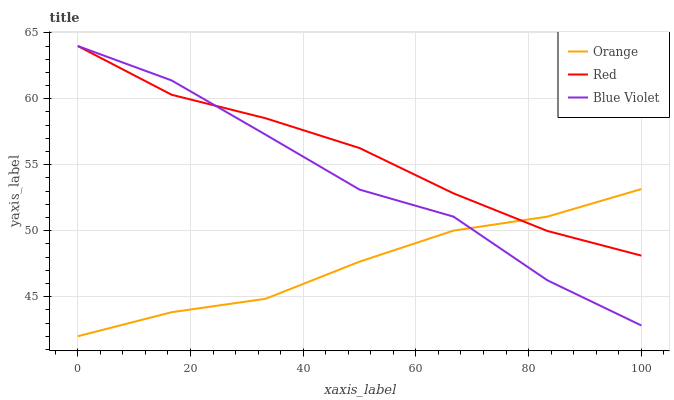Does Orange have the minimum area under the curve?
Answer yes or no. Yes. Does Red have the maximum area under the curve?
Answer yes or no. Yes. Does Blue Violet have the minimum area under the curve?
Answer yes or no. No. Does Blue Violet have the maximum area under the curve?
Answer yes or no. No. Is Red the smoothest?
Answer yes or no. Yes. Is Blue Violet the roughest?
Answer yes or no. Yes. Is Blue Violet the smoothest?
Answer yes or no. No. Is Red the roughest?
Answer yes or no. No. Does Orange have the lowest value?
Answer yes or no. Yes. Does Blue Violet have the lowest value?
Answer yes or no. No. Does Red have the highest value?
Answer yes or no. Yes. Does Blue Violet intersect Red?
Answer yes or no. Yes. Is Blue Violet less than Red?
Answer yes or no. No. Is Blue Violet greater than Red?
Answer yes or no. No. 